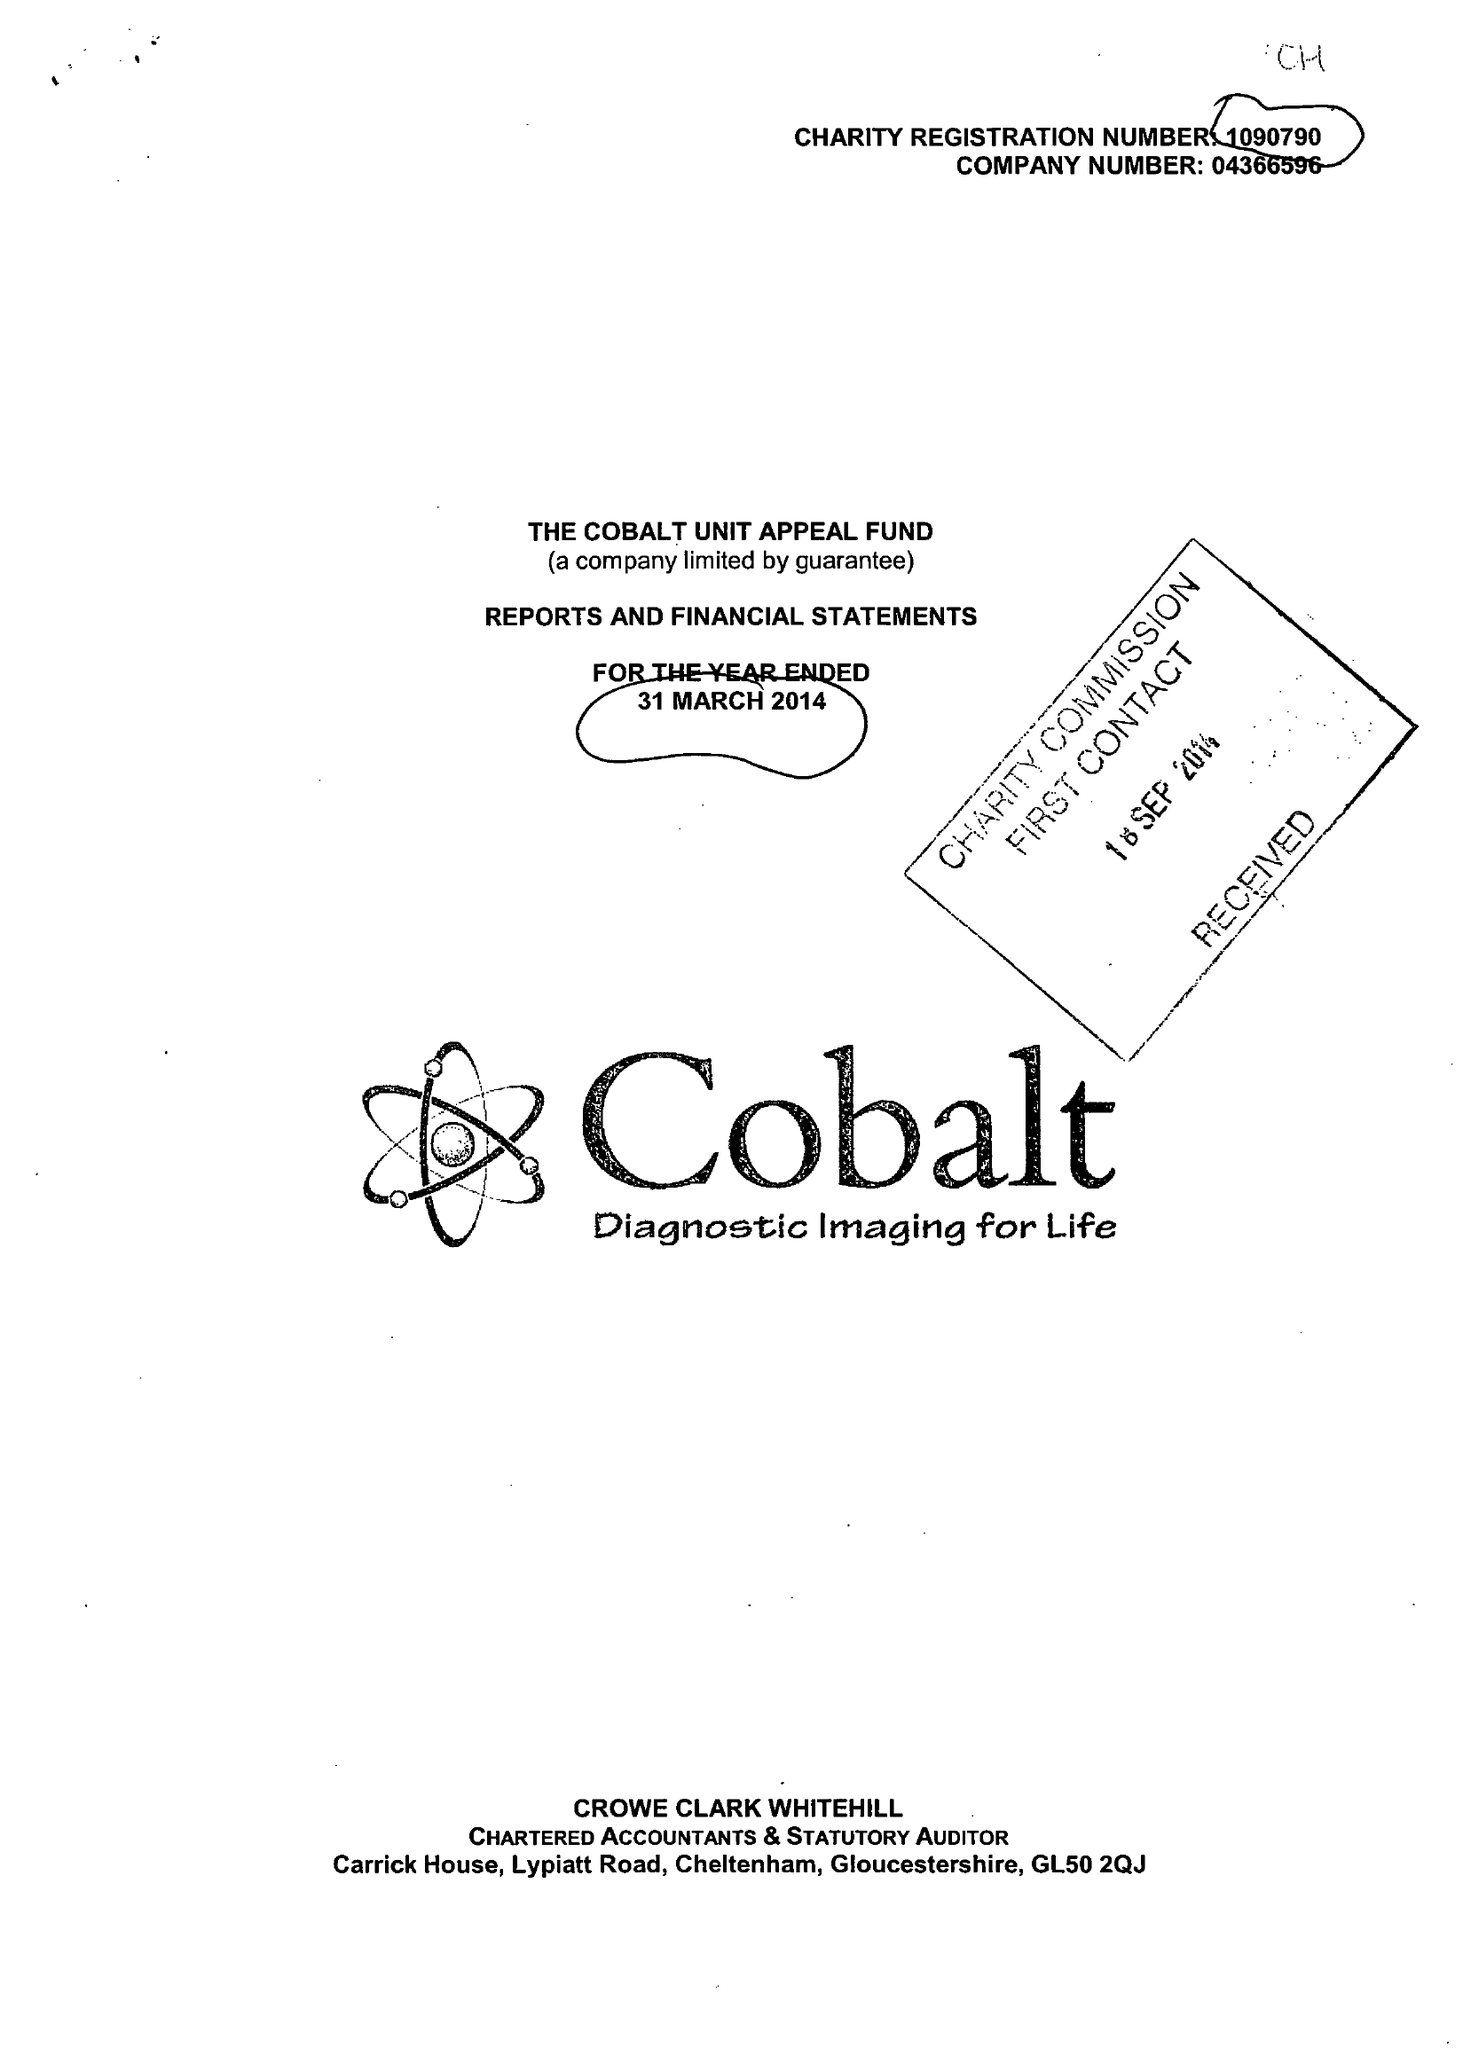What is the value for the charity_number?
Answer the question using a single word or phrase. 1090790 